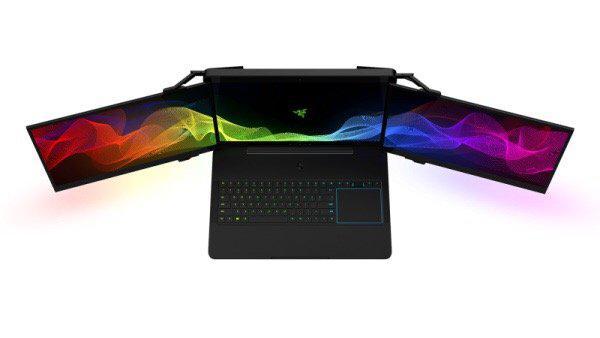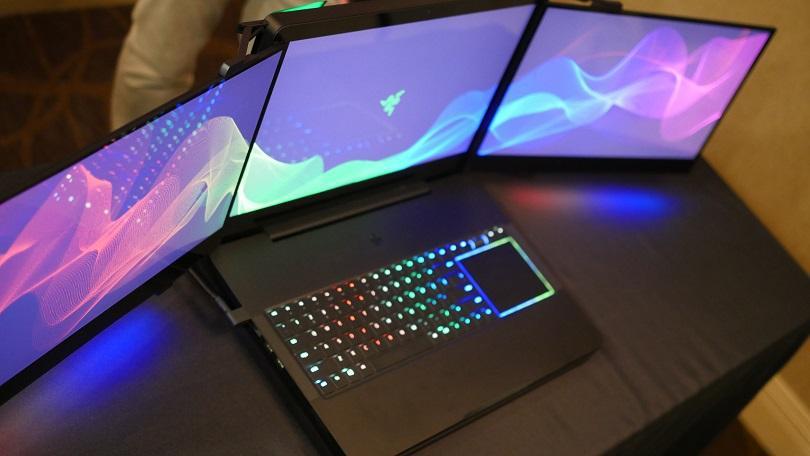The first image is the image on the left, the second image is the image on the right. For the images displayed, is the sentence "there is a latop on a desk with 2 extra monitors mounted to the original screen" factually correct? Answer yes or no. Yes. 